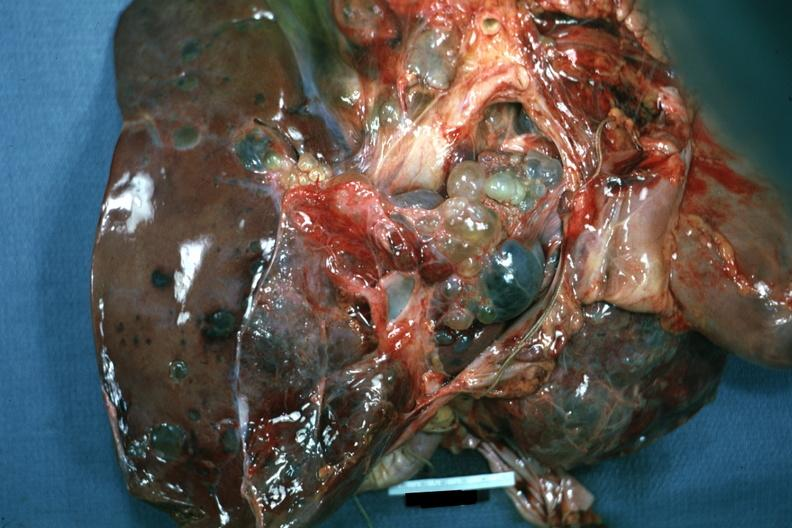does this image show case of polycystic disease lesions seen from external?
Answer the question using a single word or phrase. Yes 